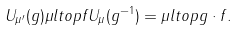<formula> <loc_0><loc_0><loc_500><loc_500>U _ { \mu ^ { \prime } } ( g ) \mu l t o p { f } U _ { \mu } ( g ^ { - 1 } ) = \mu l t o p { g \cdot f } .</formula> 